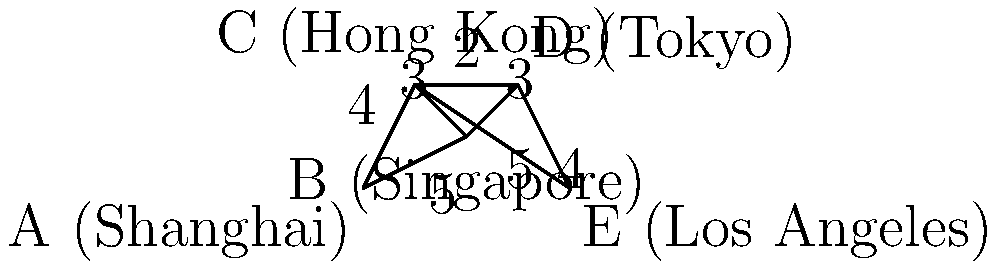作为一名物流经理，您需要找出从上海（A）到洛杉矶（E）的最短航运路线。给定上图中的国际航运路线网络，其中边上的数字表示航程距离（以天为单位），请计算最短路径的总航程时间。 要找出从上海（A）到洛杉矶（E）的最短路径，我们可以使用Dijkstra算法或者简单地列举所有可能的路径并比较它们的总距离。在这个例子中，我们将列举所有可能的路径：

1. A → B → C → D → E: 5 + 3 + 2 + 4 = 14天
2. A → B → D → E: 5 + 3 + 4 = 12天
3. A → C → D → E: 4 + 2 + 4 = 10天
4. A → C → E: 4 + 5 = 9天

通过比较这些路径，我们可以看出A → C → E是最短的路径，总航程时间为9天。

这条路线的优势在于：
1. 直接从上海到香港，避开了新加坡的中转。
2. 从香港直接到洛杉矶，不需要经过东京。

作为物流经理，选择这条路线可以最大程度地减少运输时间，提高货物周转率，同时可能降低运输成本。
Answer: 9天 